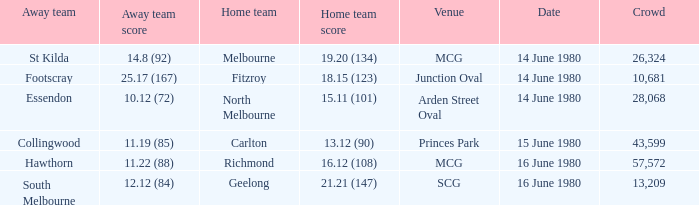On what date the footscray's away game? 14 June 1980. 